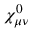<formula> <loc_0><loc_0><loc_500><loc_500>\chi _ { \mu \nu } ^ { 0 }</formula> 